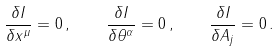Convert formula to latex. <formula><loc_0><loc_0><loc_500><loc_500>\frac { \delta I } { \delta x ^ { \mu } } = 0 \, , \quad \frac { \delta I } { \delta \theta ^ { \alpha } } = 0 \, , \quad \frac { \delta I } { \delta A _ { j } } = 0 \, .</formula> 